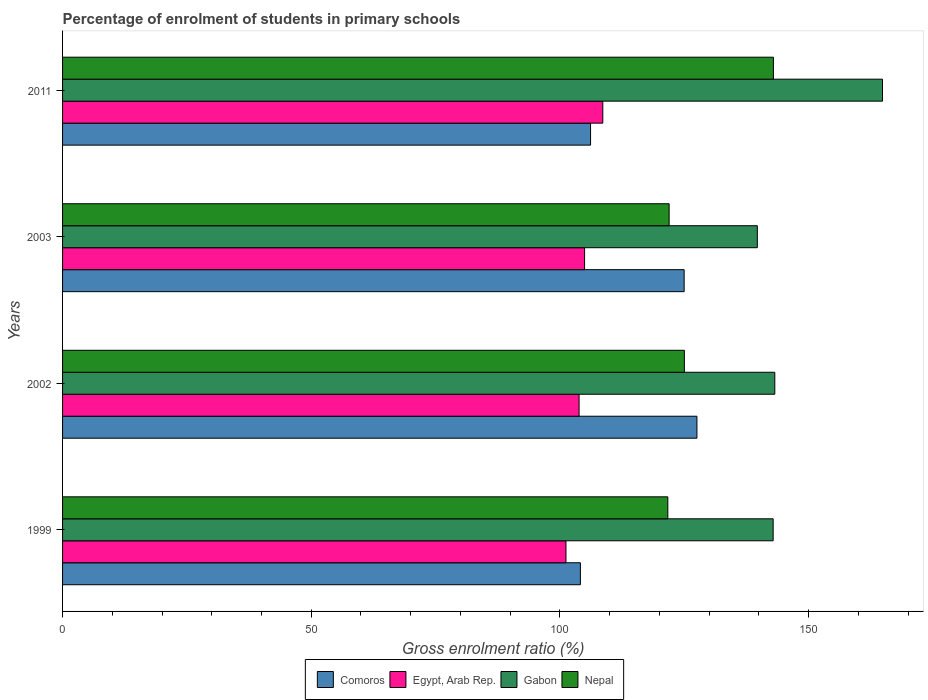How many different coloured bars are there?
Ensure brevity in your answer.  4. How many groups of bars are there?
Keep it short and to the point. 4. Are the number of bars per tick equal to the number of legend labels?
Give a very brief answer. Yes. Are the number of bars on each tick of the Y-axis equal?
Provide a succinct answer. Yes. How many bars are there on the 3rd tick from the top?
Offer a very short reply. 4. How many bars are there on the 2nd tick from the bottom?
Your answer should be compact. 4. What is the percentage of students enrolled in primary schools in Gabon in 2002?
Offer a very short reply. 143.21. Across all years, what is the maximum percentage of students enrolled in primary schools in Nepal?
Your answer should be very brief. 142.92. Across all years, what is the minimum percentage of students enrolled in primary schools in Nepal?
Give a very brief answer. 121.7. In which year was the percentage of students enrolled in primary schools in Nepal minimum?
Your answer should be compact. 1999. What is the total percentage of students enrolled in primary schools in Gabon in the graph?
Give a very brief answer. 590.63. What is the difference between the percentage of students enrolled in primary schools in Gabon in 1999 and that in 2011?
Your response must be concise. -21.98. What is the difference between the percentage of students enrolled in primary schools in Nepal in 2011 and the percentage of students enrolled in primary schools in Comoros in 1999?
Make the answer very short. 38.81. What is the average percentage of students enrolled in primary schools in Comoros per year?
Keep it short and to the point. 115.7. In the year 2002, what is the difference between the percentage of students enrolled in primary schools in Nepal and percentage of students enrolled in primary schools in Comoros?
Provide a short and direct response. -2.53. In how many years, is the percentage of students enrolled in primary schools in Comoros greater than 80 %?
Offer a very short reply. 4. What is the ratio of the percentage of students enrolled in primary schools in Nepal in 2003 to that in 2011?
Your response must be concise. 0.85. Is the percentage of students enrolled in primary schools in Egypt, Arab Rep. in 2002 less than that in 2003?
Make the answer very short. Yes. Is the difference between the percentage of students enrolled in primary schools in Nepal in 2003 and 2011 greater than the difference between the percentage of students enrolled in primary schools in Comoros in 2003 and 2011?
Provide a short and direct response. No. What is the difference between the highest and the second highest percentage of students enrolled in primary schools in Gabon?
Your response must be concise. 21.65. What is the difference between the highest and the lowest percentage of students enrolled in primary schools in Comoros?
Give a very brief answer. 23.43. In how many years, is the percentage of students enrolled in primary schools in Gabon greater than the average percentage of students enrolled in primary schools in Gabon taken over all years?
Offer a terse response. 1. Is the sum of the percentage of students enrolled in primary schools in Nepal in 1999 and 2011 greater than the maximum percentage of students enrolled in primary schools in Gabon across all years?
Keep it short and to the point. Yes. Is it the case that in every year, the sum of the percentage of students enrolled in primary schools in Gabon and percentage of students enrolled in primary schools in Comoros is greater than the sum of percentage of students enrolled in primary schools in Egypt, Arab Rep. and percentage of students enrolled in primary schools in Nepal?
Offer a terse response. Yes. What does the 4th bar from the top in 2011 represents?
Ensure brevity in your answer.  Comoros. What does the 1st bar from the bottom in 2002 represents?
Offer a very short reply. Comoros. Are all the bars in the graph horizontal?
Offer a terse response. Yes. How many years are there in the graph?
Give a very brief answer. 4. Are the values on the major ticks of X-axis written in scientific E-notation?
Give a very brief answer. No. Does the graph contain any zero values?
Keep it short and to the point. No. What is the title of the graph?
Your response must be concise. Percentage of enrolment of students in primary schools. Does "Comoros" appear as one of the legend labels in the graph?
Keep it short and to the point. Yes. What is the label or title of the X-axis?
Your answer should be compact. Gross enrolment ratio (%). What is the Gross enrolment ratio (%) of Comoros in 1999?
Give a very brief answer. 104.11. What is the Gross enrolment ratio (%) of Egypt, Arab Rep. in 1999?
Keep it short and to the point. 101.22. What is the Gross enrolment ratio (%) of Gabon in 1999?
Provide a short and direct response. 142.87. What is the Gross enrolment ratio (%) in Nepal in 1999?
Ensure brevity in your answer.  121.7. What is the Gross enrolment ratio (%) in Comoros in 2002?
Give a very brief answer. 127.55. What is the Gross enrolment ratio (%) of Egypt, Arab Rep. in 2002?
Offer a terse response. 103.86. What is the Gross enrolment ratio (%) of Gabon in 2002?
Keep it short and to the point. 143.21. What is the Gross enrolment ratio (%) of Nepal in 2002?
Ensure brevity in your answer.  125.02. What is the Gross enrolment ratio (%) in Comoros in 2003?
Make the answer very short. 124.98. What is the Gross enrolment ratio (%) of Egypt, Arab Rep. in 2003?
Provide a short and direct response. 104.96. What is the Gross enrolment ratio (%) of Gabon in 2003?
Provide a short and direct response. 139.69. What is the Gross enrolment ratio (%) in Nepal in 2003?
Provide a short and direct response. 121.96. What is the Gross enrolment ratio (%) in Comoros in 2011?
Your response must be concise. 106.16. What is the Gross enrolment ratio (%) of Egypt, Arab Rep. in 2011?
Provide a short and direct response. 108.62. What is the Gross enrolment ratio (%) in Gabon in 2011?
Make the answer very short. 164.86. What is the Gross enrolment ratio (%) in Nepal in 2011?
Provide a succinct answer. 142.92. Across all years, what is the maximum Gross enrolment ratio (%) of Comoros?
Keep it short and to the point. 127.55. Across all years, what is the maximum Gross enrolment ratio (%) in Egypt, Arab Rep.?
Your answer should be very brief. 108.62. Across all years, what is the maximum Gross enrolment ratio (%) of Gabon?
Your answer should be compact. 164.86. Across all years, what is the maximum Gross enrolment ratio (%) in Nepal?
Your answer should be very brief. 142.92. Across all years, what is the minimum Gross enrolment ratio (%) in Comoros?
Your answer should be compact. 104.11. Across all years, what is the minimum Gross enrolment ratio (%) of Egypt, Arab Rep.?
Offer a very short reply. 101.22. Across all years, what is the minimum Gross enrolment ratio (%) in Gabon?
Give a very brief answer. 139.69. Across all years, what is the minimum Gross enrolment ratio (%) in Nepal?
Your answer should be very brief. 121.7. What is the total Gross enrolment ratio (%) in Comoros in the graph?
Give a very brief answer. 462.8. What is the total Gross enrolment ratio (%) in Egypt, Arab Rep. in the graph?
Ensure brevity in your answer.  418.65. What is the total Gross enrolment ratio (%) of Gabon in the graph?
Your answer should be very brief. 590.63. What is the total Gross enrolment ratio (%) of Nepal in the graph?
Provide a succinct answer. 511.6. What is the difference between the Gross enrolment ratio (%) of Comoros in 1999 and that in 2002?
Ensure brevity in your answer.  -23.43. What is the difference between the Gross enrolment ratio (%) of Egypt, Arab Rep. in 1999 and that in 2002?
Offer a terse response. -2.64. What is the difference between the Gross enrolment ratio (%) in Gabon in 1999 and that in 2002?
Your response must be concise. -0.33. What is the difference between the Gross enrolment ratio (%) in Nepal in 1999 and that in 2002?
Provide a short and direct response. -3.32. What is the difference between the Gross enrolment ratio (%) in Comoros in 1999 and that in 2003?
Your response must be concise. -20.86. What is the difference between the Gross enrolment ratio (%) of Egypt, Arab Rep. in 1999 and that in 2003?
Give a very brief answer. -3.74. What is the difference between the Gross enrolment ratio (%) in Gabon in 1999 and that in 2003?
Provide a short and direct response. 3.18. What is the difference between the Gross enrolment ratio (%) in Nepal in 1999 and that in 2003?
Your answer should be very brief. -0.26. What is the difference between the Gross enrolment ratio (%) of Comoros in 1999 and that in 2011?
Offer a terse response. -2.05. What is the difference between the Gross enrolment ratio (%) in Egypt, Arab Rep. in 1999 and that in 2011?
Make the answer very short. -7.41. What is the difference between the Gross enrolment ratio (%) in Gabon in 1999 and that in 2011?
Give a very brief answer. -21.98. What is the difference between the Gross enrolment ratio (%) in Nepal in 1999 and that in 2011?
Provide a short and direct response. -21.23. What is the difference between the Gross enrolment ratio (%) in Comoros in 2002 and that in 2003?
Your response must be concise. 2.57. What is the difference between the Gross enrolment ratio (%) of Egypt, Arab Rep. in 2002 and that in 2003?
Make the answer very short. -1.1. What is the difference between the Gross enrolment ratio (%) of Gabon in 2002 and that in 2003?
Ensure brevity in your answer.  3.51. What is the difference between the Gross enrolment ratio (%) of Nepal in 2002 and that in 2003?
Offer a very short reply. 3.06. What is the difference between the Gross enrolment ratio (%) of Comoros in 2002 and that in 2011?
Your answer should be very brief. 21.39. What is the difference between the Gross enrolment ratio (%) in Egypt, Arab Rep. in 2002 and that in 2011?
Ensure brevity in your answer.  -4.77. What is the difference between the Gross enrolment ratio (%) in Gabon in 2002 and that in 2011?
Provide a short and direct response. -21.65. What is the difference between the Gross enrolment ratio (%) in Nepal in 2002 and that in 2011?
Give a very brief answer. -17.9. What is the difference between the Gross enrolment ratio (%) in Comoros in 2003 and that in 2011?
Keep it short and to the point. 18.82. What is the difference between the Gross enrolment ratio (%) of Egypt, Arab Rep. in 2003 and that in 2011?
Your answer should be very brief. -3.66. What is the difference between the Gross enrolment ratio (%) in Gabon in 2003 and that in 2011?
Your response must be concise. -25.17. What is the difference between the Gross enrolment ratio (%) of Nepal in 2003 and that in 2011?
Offer a terse response. -20.96. What is the difference between the Gross enrolment ratio (%) in Comoros in 1999 and the Gross enrolment ratio (%) in Egypt, Arab Rep. in 2002?
Provide a succinct answer. 0.26. What is the difference between the Gross enrolment ratio (%) in Comoros in 1999 and the Gross enrolment ratio (%) in Gabon in 2002?
Your answer should be compact. -39.09. What is the difference between the Gross enrolment ratio (%) of Comoros in 1999 and the Gross enrolment ratio (%) of Nepal in 2002?
Make the answer very short. -20.91. What is the difference between the Gross enrolment ratio (%) of Egypt, Arab Rep. in 1999 and the Gross enrolment ratio (%) of Gabon in 2002?
Provide a succinct answer. -41.99. What is the difference between the Gross enrolment ratio (%) in Egypt, Arab Rep. in 1999 and the Gross enrolment ratio (%) in Nepal in 2002?
Your answer should be compact. -23.81. What is the difference between the Gross enrolment ratio (%) in Gabon in 1999 and the Gross enrolment ratio (%) in Nepal in 2002?
Keep it short and to the point. 17.85. What is the difference between the Gross enrolment ratio (%) of Comoros in 1999 and the Gross enrolment ratio (%) of Egypt, Arab Rep. in 2003?
Offer a terse response. -0.84. What is the difference between the Gross enrolment ratio (%) of Comoros in 1999 and the Gross enrolment ratio (%) of Gabon in 2003?
Your response must be concise. -35.58. What is the difference between the Gross enrolment ratio (%) in Comoros in 1999 and the Gross enrolment ratio (%) in Nepal in 2003?
Your answer should be very brief. -17.85. What is the difference between the Gross enrolment ratio (%) in Egypt, Arab Rep. in 1999 and the Gross enrolment ratio (%) in Gabon in 2003?
Give a very brief answer. -38.48. What is the difference between the Gross enrolment ratio (%) of Egypt, Arab Rep. in 1999 and the Gross enrolment ratio (%) of Nepal in 2003?
Your answer should be compact. -20.75. What is the difference between the Gross enrolment ratio (%) of Gabon in 1999 and the Gross enrolment ratio (%) of Nepal in 2003?
Your answer should be very brief. 20.91. What is the difference between the Gross enrolment ratio (%) in Comoros in 1999 and the Gross enrolment ratio (%) in Egypt, Arab Rep. in 2011?
Your answer should be compact. -4.51. What is the difference between the Gross enrolment ratio (%) of Comoros in 1999 and the Gross enrolment ratio (%) of Gabon in 2011?
Your answer should be very brief. -60.74. What is the difference between the Gross enrolment ratio (%) in Comoros in 1999 and the Gross enrolment ratio (%) in Nepal in 2011?
Give a very brief answer. -38.81. What is the difference between the Gross enrolment ratio (%) of Egypt, Arab Rep. in 1999 and the Gross enrolment ratio (%) of Gabon in 2011?
Ensure brevity in your answer.  -63.64. What is the difference between the Gross enrolment ratio (%) in Egypt, Arab Rep. in 1999 and the Gross enrolment ratio (%) in Nepal in 2011?
Provide a succinct answer. -41.71. What is the difference between the Gross enrolment ratio (%) in Gabon in 1999 and the Gross enrolment ratio (%) in Nepal in 2011?
Provide a short and direct response. -0.05. What is the difference between the Gross enrolment ratio (%) in Comoros in 2002 and the Gross enrolment ratio (%) in Egypt, Arab Rep. in 2003?
Keep it short and to the point. 22.59. What is the difference between the Gross enrolment ratio (%) of Comoros in 2002 and the Gross enrolment ratio (%) of Gabon in 2003?
Your answer should be very brief. -12.14. What is the difference between the Gross enrolment ratio (%) of Comoros in 2002 and the Gross enrolment ratio (%) of Nepal in 2003?
Provide a succinct answer. 5.59. What is the difference between the Gross enrolment ratio (%) of Egypt, Arab Rep. in 2002 and the Gross enrolment ratio (%) of Gabon in 2003?
Give a very brief answer. -35.84. What is the difference between the Gross enrolment ratio (%) in Egypt, Arab Rep. in 2002 and the Gross enrolment ratio (%) in Nepal in 2003?
Keep it short and to the point. -18.11. What is the difference between the Gross enrolment ratio (%) of Gabon in 2002 and the Gross enrolment ratio (%) of Nepal in 2003?
Your answer should be very brief. 21.24. What is the difference between the Gross enrolment ratio (%) in Comoros in 2002 and the Gross enrolment ratio (%) in Egypt, Arab Rep. in 2011?
Offer a very short reply. 18.93. What is the difference between the Gross enrolment ratio (%) in Comoros in 2002 and the Gross enrolment ratio (%) in Gabon in 2011?
Offer a terse response. -37.31. What is the difference between the Gross enrolment ratio (%) of Comoros in 2002 and the Gross enrolment ratio (%) of Nepal in 2011?
Provide a succinct answer. -15.37. What is the difference between the Gross enrolment ratio (%) in Egypt, Arab Rep. in 2002 and the Gross enrolment ratio (%) in Gabon in 2011?
Ensure brevity in your answer.  -61. What is the difference between the Gross enrolment ratio (%) of Egypt, Arab Rep. in 2002 and the Gross enrolment ratio (%) of Nepal in 2011?
Your answer should be very brief. -39.07. What is the difference between the Gross enrolment ratio (%) of Gabon in 2002 and the Gross enrolment ratio (%) of Nepal in 2011?
Keep it short and to the point. 0.28. What is the difference between the Gross enrolment ratio (%) in Comoros in 2003 and the Gross enrolment ratio (%) in Egypt, Arab Rep. in 2011?
Ensure brevity in your answer.  16.36. What is the difference between the Gross enrolment ratio (%) of Comoros in 2003 and the Gross enrolment ratio (%) of Gabon in 2011?
Keep it short and to the point. -39.88. What is the difference between the Gross enrolment ratio (%) in Comoros in 2003 and the Gross enrolment ratio (%) in Nepal in 2011?
Your answer should be compact. -17.94. What is the difference between the Gross enrolment ratio (%) of Egypt, Arab Rep. in 2003 and the Gross enrolment ratio (%) of Gabon in 2011?
Offer a terse response. -59.9. What is the difference between the Gross enrolment ratio (%) of Egypt, Arab Rep. in 2003 and the Gross enrolment ratio (%) of Nepal in 2011?
Provide a succinct answer. -37.97. What is the difference between the Gross enrolment ratio (%) of Gabon in 2003 and the Gross enrolment ratio (%) of Nepal in 2011?
Provide a succinct answer. -3.23. What is the average Gross enrolment ratio (%) in Comoros per year?
Offer a terse response. 115.7. What is the average Gross enrolment ratio (%) of Egypt, Arab Rep. per year?
Give a very brief answer. 104.66. What is the average Gross enrolment ratio (%) in Gabon per year?
Your answer should be compact. 147.66. What is the average Gross enrolment ratio (%) in Nepal per year?
Offer a very short reply. 127.9. In the year 1999, what is the difference between the Gross enrolment ratio (%) of Comoros and Gross enrolment ratio (%) of Egypt, Arab Rep.?
Provide a succinct answer. 2.9. In the year 1999, what is the difference between the Gross enrolment ratio (%) in Comoros and Gross enrolment ratio (%) in Gabon?
Provide a succinct answer. -38.76. In the year 1999, what is the difference between the Gross enrolment ratio (%) in Comoros and Gross enrolment ratio (%) in Nepal?
Your answer should be compact. -17.58. In the year 1999, what is the difference between the Gross enrolment ratio (%) of Egypt, Arab Rep. and Gross enrolment ratio (%) of Gabon?
Make the answer very short. -41.66. In the year 1999, what is the difference between the Gross enrolment ratio (%) in Egypt, Arab Rep. and Gross enrolment ratio (%) in Nepal?
Provide a succinct answer. -20.48. In the year 1999, what is the difference between the Gross enrolment ratio (%) in Gabon and Gross enrolment ratio (%) in Nepal?
Make the answer very short. 21.18. In the year 2002, what is the difference between the Gross enrolment ratio (%) in Comoros and Gross enrolment ratio (%) in Egypt, Arab Rep.?
Provide a succinct answer. 23.69. In the year 2002, what is the difference between the Gross enrolment ratio (%) in Comoros and Gross enrolment ratio (%) in Gabon?
Offer a terse response. -15.66. In the year 2002, what is the difference between the Gross enrolment ratio (%) in Comoros and Gross enrolment ratio (%) in Nepal?
Make the answer very short. 2.53. In the year 2002, what is the difference between the Gross enrolment ratio (%) of Egypt, Arab Rep. and Gross enrolment ratio (%) of Gabon?
Your response must be concise. -39.35. In the year 2002, what is the difference between the Gross enrolment ratio (%) of Egypt, Arab Rep. and Gross enrolment ratio (%) of Nepal?
Your answer should be very brief. -21.17. In the year 2002, what is the difference between the Gross enrolment ratio (%) in Gabon and Gross enrolment ratio (%) in Nepal?
Your response must be concise. 18.18. In the year 2003, what is the difference between the Gross enrolment ratio (%) of Comoros and Gross enrolment ratio (%) of Egypt, Arab Rep.?
Your answer should be compact. 20.02. In the year 2003, what is the difference between the Gross enrolment ratio (%) in Comoros and Gross enrolment ratio (%) in Gabon?
Provide a succinct answer. -14.71. In the year 2003, what is the difference between the Gross enrolment ratio (%) of Comoros and Gross enrolment ratio (%) of Nepal?
Ensure brevity in your answer.  3.02. In the year 2003, what is the difference between the Gross enrolment ratio (%) in Egypt, Arab Rep. and Gross enrolment ratio (%) in Gabon?
Give a very brief answer. -34.73. In the year 2003, what is the difference between the Gross enrolment ratio (%) of Egypt, Arab Rep. and Gross enrolment ratio (%) of Nepal?
Make the answer very short. -17. In the year 2003, what is the difference between the Gross enrolment ratio (%) of Gabon and Gross enrolment ratio (%) of Nepal?
Your response must be concise. 17.73. In the year 2011, what is the difference between the Gross enrolment ratio (%) of Comoros and Gross enrolment ratio (%) of Egypt, Arab Rep.?
Ensure brevity in your answer.  -2.46. In the year 2011, what is the difference between the Gross enrolment ratio (%) of Comoros and Gross enrolment ratio (%) of Gabon?
Give a very brief answer. -58.7. In the year 2011, what is the difference between the Gross enrolment ratio (%) of Comoros and Gross enrolment ratio (%) of Nepal?
Ensure brevity in your answer.  -36.76. In the year 2011, what is the difference between the Gross enrolment ratio (%) of Egypt, Arab Rep. and Gross enrolment ratio (%) of Gabon?
Ensure brevity in your answer.  -56.24. In the year 2011, what is the difference between the Gross enrolment ratio (%) of Egypt, Arab Rep. and Gross enrolment ratio (%) of Nepal?
Offer a terse response. -34.3. In the year 2011, what is the difference between the Gross enrolment ratio (%) of Gabon and Gross enrolment ratio (%) of Nepal?
Your answer should be compact. 21.94. What is the ratio of the Gross enrolment ratio (%) in Comoros in 1999 to that in 2002?
Offer a very short reply. 0.82. What is the ratio of the Gross enrolment ratio (%) of Egypt, Arab Rep. in 1999 to that in 2002?
Keep it short and to the point. 0.97. What is the ratio of the Gross enrolment ratio (%) in Gabon in 1999 to that in 2002?
Your answer should be very brief. 1. What is the ratio of the Gross enrolment ratio (%) in Nepal in 1999 to that in 2002?
Your response must be concise. 0.97. What is the ratio of the Gross enrolment ratio (%) in Comoros in 1999 to that in 2003?
Offer a very short reply. 0.83. What is the ratio of the Gross enrolment ratio (%) in Egypt, Arab Rep. in 1999 to that in 2003?
Give a very brief answer. 0.96. What is the ratio of the Gross enrolment ratio (%) of Gabon in 1999 to that in 2003?
Make the answer very short. 1.02. What is the ratio of the Gross enrolment ratio (%) in Comoros in 1999 to that in 2011?
Your answer should be compact. 0.98. What is the ratio of the Gross enrolment ratio (%) in Egypt, Arab Rep. in 1999 to that in 2011?
Offer a terse response. 0.93. What is the ratio of the Gross enrolment ratio (%) in Gabon in 1999 to that in 2011?
Your answer should be very brief. 0.87. What is the ratio of the Gross enrolment ratio (%) of Nepal in 1999 to that in 2011?
Offer a terse response. 0.85. What is the ratio of the Gross enrolment ratio (%) in Comoros in 2002 to that in 2003?
Provide a succinct answer. 1.02. What is the ratio of the Gross enrolment ratio (%) in Gabon in 2002 to that in 2003?
Your response must be concise. 1.03. What is the ratio of the Gross enrolment ratio (%) of Nepal in 2002 to that in 2003?
Make the answer very short. 1.03. What is the ratio of the Gross enrolment ratio (%) in Comoros in 2002 to that in 2011?
Your answer should be very brief. 1.2. What is the ratio of the Gross enrolment ratio (%) in Egypt, Arab Rep. in 2002 to that in 2011?
Offer a very short reply. 0.96. What is the ratio of the Gross enrolment ratio (%) in Gabon in 2002 to that in 2011?
Make the answer very short. 0.87. What is the ratio of the Gross enrolment ratio (%) in Nepal in 2002 to that in 2011?
Keep it short and to the point. 0.87. What is the ratio of the Gross enrolment ratio (%) in Comoros in 2003 to that in 2011?
Keep it short and to the point. 1.18. What is the ratio of the Gross enrolment ratio (%) of Egypt, Arab Rep. in 2003 to that in 2011?
Give a very brief answer. 0.97. What is the ratio of the Gross enrolment ratio (%) of Gabon in 2003 to that in 2011?
Keep it short and to the point. 0.85. What is the ratio of the Gross enrolment ratio (%) of Nepal in 2003 to that in 2011?
Offer a terse response. 0.85. What is the difference between the highest and the second highest Gross enrolment ratio (%) of Comoros?
Keep it short and to the point. 2.57. What is the difference between the highest and the second highest Gross enrolment ratio (%) in Egypt, Arab Rep.?
Keep it short and to the point. 3.66. What is the difference between the highest and the second highest Gross enrolment ratio (%) in Gabon?
Make the answer very short. 21.65. What is the difference between the highest and the second highest Gross enrolment ratio (%) of Nepal?
Offer a very short reply. 17.9. What is the difference between the highest and the lowest Gross enrolment ratio (%) of Comoros?
Provide a short and direct response. 23.43. What is the difference between the highest and the lowest Gross enrolment ratio (%) in Egypt, Arab Rep.?
Your answer should be compact. 7.41. What is the difference between the highest and the lowest Gross enrolment ratio (%) of Gabon?
Provide a short and direct response. 25.17. What is the difference between the highest and the lowest Gross enrolment ratio (%) of Nepal?
Provide a short and direct response. 21.23. 